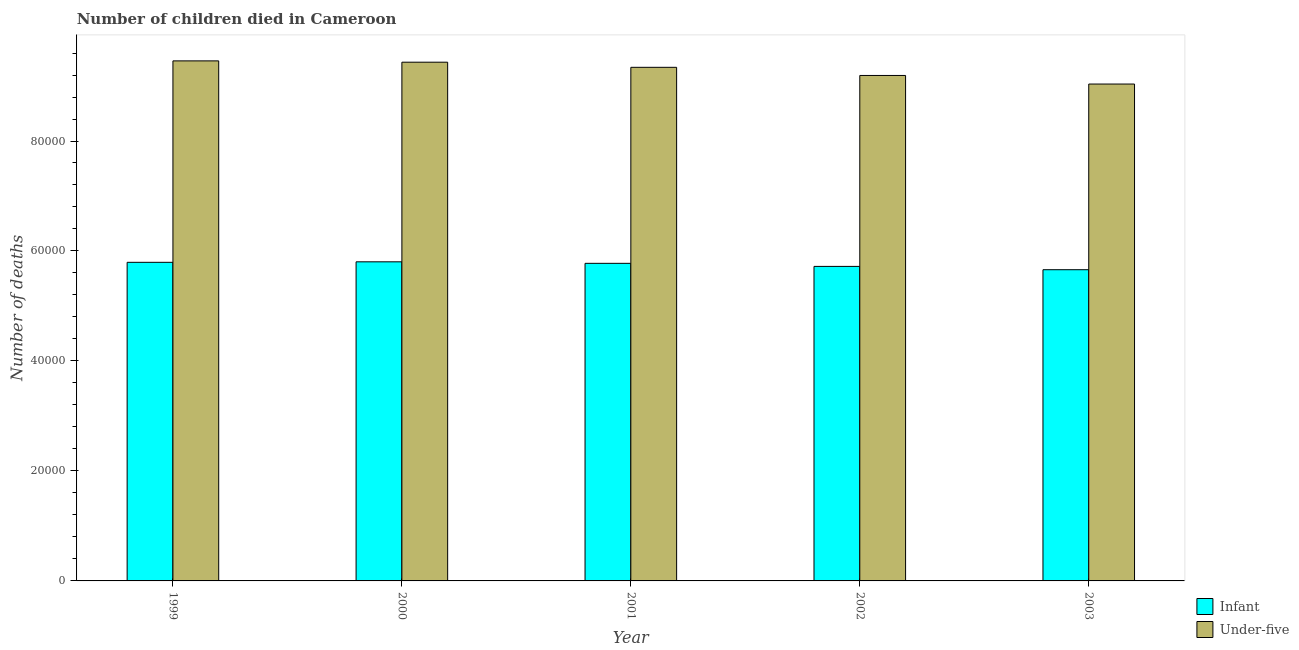How many groups of bars are there?
Your answer should be compact. 5. Are the number of bars per tick equal to the number of legend labels?
Keep it short and to the point. Yes. How many bars are there on the 5th tick from the left?
Make the answer very short. 2. What is the label of the 1st group of bars from the left?
Ensure brevity in your answer.  1999. What is the number of infant deaths in 2002?
Offer a terse response. 5.72e+04. Across all years, what is the maximum number of infant deaths?
Provide a succinct answer. 5.80e+04. Across all years, what is the minimum number of infant deaths?
Your answer should be compact. 5.66e+04. In which year was the number of under-five deaths minimum?
Your response must be concise. 2003. What is the total number of under-five deaths in the graph?
Offer a very short reply. 4.65e+05. What is the difference between the number of infant deaths in 2000 and that in 2002?
Your answer should be compact. 832. What is the difference between the number of infant deaths in 2000 and the number of under-five deaths in 2002?
Provide a short and direct response. 832. What is the average number of under-five deaths per year?
Give a very brief answer. 9.29e+04. In the year 2001, what is the difference between the number of under-five deaths and number of infant deaths?
Provide a short and direct response. 0. What is the ratio of the number of infant deaths in 2000 to that in 2002?
Provide a succinct answer. 1.01. Is the number of under-five deaths in 2001 less than that in 2003?
Your response must be concise. No. What is the difference between the highest and the second highest number of under-five deaths?
Give a very brief answer. 239. What is the difference between the highest and the lowest number of under-five deaths?
Keep it short and to the point. 4213. In how many years, is the number of under-five deaths greater than the average number of under-five deaths taken over all years?
Your response must be concise. 3. What does the 1st bar from the left in 2003 represents?
Offer a very short reply. Infant. What does the 1st bar from the right in 2003 represents?
Offer a terse response. Under-five. How many years are there in the graph?
Keep it short and to the point. 5. What is the difference between two consecutive major ticks on the Y-axis?
Provide a succinct answer. 2.00e+04. Does the graph contain any zero values?
Offer a very short reply. No. Does the graph contain grids?
Your answer should be compact. No. Where does the legend appear in the graph?
Your answer should be compact. Bottom right. How many legend labels are there?
Give a very brief answer. 2. What is the title of the graph?
Provide a succinct answer. Number of children died in Cameroon. Does "GDP at market prices" appear as one of the legend labels in the graph?
Give a very brief answer. No. What is the label or title of the X-axis?
Offer a terse response. Year. What is the label or title of the Y-axis?
Your answer should be very brief. Number of deaths. What is the Number of deaths in Infant in 1999?
Keep it short and to the point. 5.79e+04. What is the Number of deaths in Under-five in 1999?
Your answer should be very brief. 9.46e+04. What is the Number of deaths in Infant in 2000?
Provide a short and direct response. 5.80e+04. What is the Number of deaths of Under-five in 2000?
Your response must be concise. 9.43e+04. What is the Number of deaths of Infant in 2001?
Your response must be concise. 5.78e+04. What is the Number of deaths of Under-five in 2001?
Your answer should be very brief. 9.34e+04. What is the Number of deaths in Infant in 2002?
Keep it short and to the point. 5.72e+04. What is the Number of deaths in Under-five in 2002?
Ensure brevity in your answer.  9.19e+04. What is the Number of deaths in Infant in 2003?
Your response must be concise. 5.66e+04. What is the Number of deaths of Under-five in 2003?
Give a very brief answer. 9.04e+04. Across all years, what is the maximum Number of deaths of Infant?
Provide a succinct answer. 5.80e+04. Across all years, what is the maximum Number of deaths in Under-five?
Your answer should be very brief. 9.46e+04. Across all years, what is the minimum Number of deaths in Infant?
Your answer should be compact. 5.66e+04. Across all years, what is the minimum Number of deaths of Under-five?
Give a very brief answer. 9.04e+04. What is the total Number of deaths in Infant in the graph?
Your answer should be compact. 2.88e+05. What is the total Number of deaths in Under-five in the graph?
Your answer should be very brief. 4.65e+05. What is the difference between the Number of deaths of Infant in 1999 and that in 2000?
Ensure brevity in your answer.  -89. What is the difference between the Number of deaths in Under-five in 1999 and that in 2000?
Provide a short and direct response. 239. What is the difference between the Number of deaths of Infant in 1999 and that in 2001?
Keep it short and to the point. 186. What is the difference between the Number of deaths of Under-five in 1999 and that in 2001?
Ensure brevity in your answer.  1173. What is the difference between the Number of deaths of Infant in 1999 and that in 2002?
Your answer should be very brief. 743. What is the difference between the Number of deaths in Under-five in 1999 and that in 2002?
Your response must be concise. 2652. What is the difference between the Number of deaths of Infant in 1999 and that in 2003?
Keep it short and to the point. 1345. What is the difference between the Number of deaths in Under-five in 1999 and that in 2003?
Ensure brevity in your answer.  4213. What is the difference between the Number of deaths in Infant in 2000 and that in 2001?
Your answer should be very brief. 275. What is the difference between the Number of deaths in Under-five in 2000 and that in 2001?
Provide a short and direct response. 934. What is the difference between the Number of deaths in Infant in 2000 and that in 2002?
Your response must be concise. 832. What is the difference between the Number of deaths in Under-five in 2000 and that in 2002?
Your answer should be compact. 2413. What is the difference between the Number of deaths in Infant in 2000 and that in 2003?
Provide a short and direct response. 1434. What is the difference between the Number of deaths of Under-five in 2000 and that in 2003?
Give a very brief answer. 3974. What is the difference between the Number of deaths of Infant in 2001 and that in 2002?
Your response must be concise. 557. What is the difference between the Number of deaths in Under-five in 2001 and that in 2002?
Your answer should be compact. 1479. What is the difference between the Number of deaths of Infant in 2001 and that in 2003?
Provide a short and direct response. 1159. What is the difference between the Number of deaths in Under-five in 2001 and that in 2003?
Offer a very short reply. 3040. What is the difference between the Number of deaths of Infant in 2002 and that in 2003?
Your answer should be compact. 602. What is the difference between the Number of deaths in Under-five in 2002 and that in 2003?
Offer a very short reply. 1561. What is the difference between the Number of deaths in Infant in 1999 and the Number of deaths in Under-five in 2000?
Your answer should be compact. -3.64e+04. What is the difference between the Number of deaths in Infant in 1999 and the Number of deaths in Under-five in 2001?
Ensure brevity in your answer.  -3.55e+04. What is the difference between the Number of deaths in Infant in 1999 and the Number of deaths in Under-five in 2002?
Offer a terse response. -3.40e+04. What is the difference between the Number of deaths in Infant in 1999 and the Number of deaths in Under-five in 2003?
Your answer should be very brief. -3.24e+04. What is the difference between the Number of deaths in Infant in 2000 and the Number of deaths in Under-five in 2001?
Your response must be concise. -3.54e+04. What is the difference between the Number of deaths of Infant in 2000 and the Number of deaths of Under-five in 2002?
Make the answer very short. -3.39e+04. What is the difference between the Number of deaths in Infant in 2000 and the Number of deaths in Under-five in 2003?
Provide a succinct answer. -3.23e+04. What is the difference between the Number of deaths of Infant in 2001 and the Number of deaths of Under-five in 2002?
Offer a very short reply. -3.42e+04. What is the difference between the Number of deaths in Infant in 2001 and the Number of deaths in Under-five in 2003?
Your response must be concise. -3.26e+04. What is the difference between the Number of deaths of Infant in 2002 and the Number of deaths of Under-five in 2003?
Your answer should be compact. -3.32e+04. What is the average Number of deaths in Infant per year?
Offer a terse response. 5.75e+04. What is the average Number of deaths in Under-five per year?
Your answer should be compact. 9.29e+04. In the year 1999, what is the difference between the Number of deaths in Infant and Number of deaths in Under-five?
Offer a terse response. -3.66e+04. In the year 2000, what is the difference between the Number of deaths in Infant and Number of deaths in Under-five?
Provide a succinct answer. -3.63e+04. In the year 2001, what is the difference between the Number of deaths of Infant and Number of deaths of Under-five?
Your answer should be compact. -3.56e+04. In the year 2002, what is the difference between the Number of deaths in Infant and Number of deaths in Under-five?
Offer a terse response. -3.47e+04. In the year 2003, what is the difference between the Number of deaths in Infant and Number of deaths in Under-five?
Your response must be concise. -3.38e+04. What is the ratio of the Number of deaths in Infant in 1999 to that in 2000?
Ensure brevity in your answer.  1. What is the ratio of the Number of deaths in Under-five in 1999 to that in 2000?
Your answer should be compact. 1. What is the ratio of the Number of deaths of Infant in 1999 to that in 2001?
Offer a very short reply. 1. What is the ratio of the Number of deaths in Under-five in 1999 to that in 2001?
Keep it short and to the point. 1.01. What is the ratio of the Number of deaths of Under-five in 1999 to that in 2002?
Your response must be concise. 1.03. What is the ratio of the Number of deaths of Infant in 1999 to that in 2003?
Give a very brief answer. 1.02. What is the ratio of the Number of deaths of Under-five in 1999 to that in 2003?
Your answer should be very brief. 1.05. What is the ratio of the Number of deaths of Under-five in 2000 to that in 2001?
Offer a terse response. 1.01. What is the ratio of the Number of deaths in Infant in 2000 to that in 2002?
Your answer should be very brief. 1.01. What is the ratio of the Number of deaths in Under-five in 2000 to that in 2002?
Your answer should be compact. 1.03. What is the ratio of the Number of deaths in Infant in 2000 to that in 2003?
Offer a very short reply. 1.03. What is the ratio of the Number of deaths in Under-five in 2000 to that in 2003?
Provide a succinct answer. 1.04. What is the ratio of the Number of deaths in Infant in 2001 to that in 2002?
Ensure brevity in your answer.  1.01. What is the ratio of the Number of deaths of Under-five in 2001 to that in 2002?
Keep it short and to the point. 1.02. What is the ratio of the Number of deaths in Infant in 2001 to that in 2003?
Your answer should be compact. 1.02. What is the ratio of the Number of deaths of Under-five in 2001 to that in 2003?
Offer a terse response. 1.03. What is the ratio of the Number of deaths in Infant in 2002 to that in 2003?
Provide a short and direct response. 1.01. What is the ratio of the Number of deaths of Under-five in 2002 to that in 2003?
Give a very brief answer. 1.02. What is the difference between the highest and the second highest Number of deaths of Infant?
Offer a very short reply. 89. What is the difference between the highest and the second highest Number of deaths in Under-five?
Your answer should be compact. 239. What is the difference between the highest and the lowest Number of deaths of Infant?
Give a very brief answer. 1434. What is the difference between the highest and the lowest Number of deaths in Under-five?
Ensure brevity in your answer.  4213. 